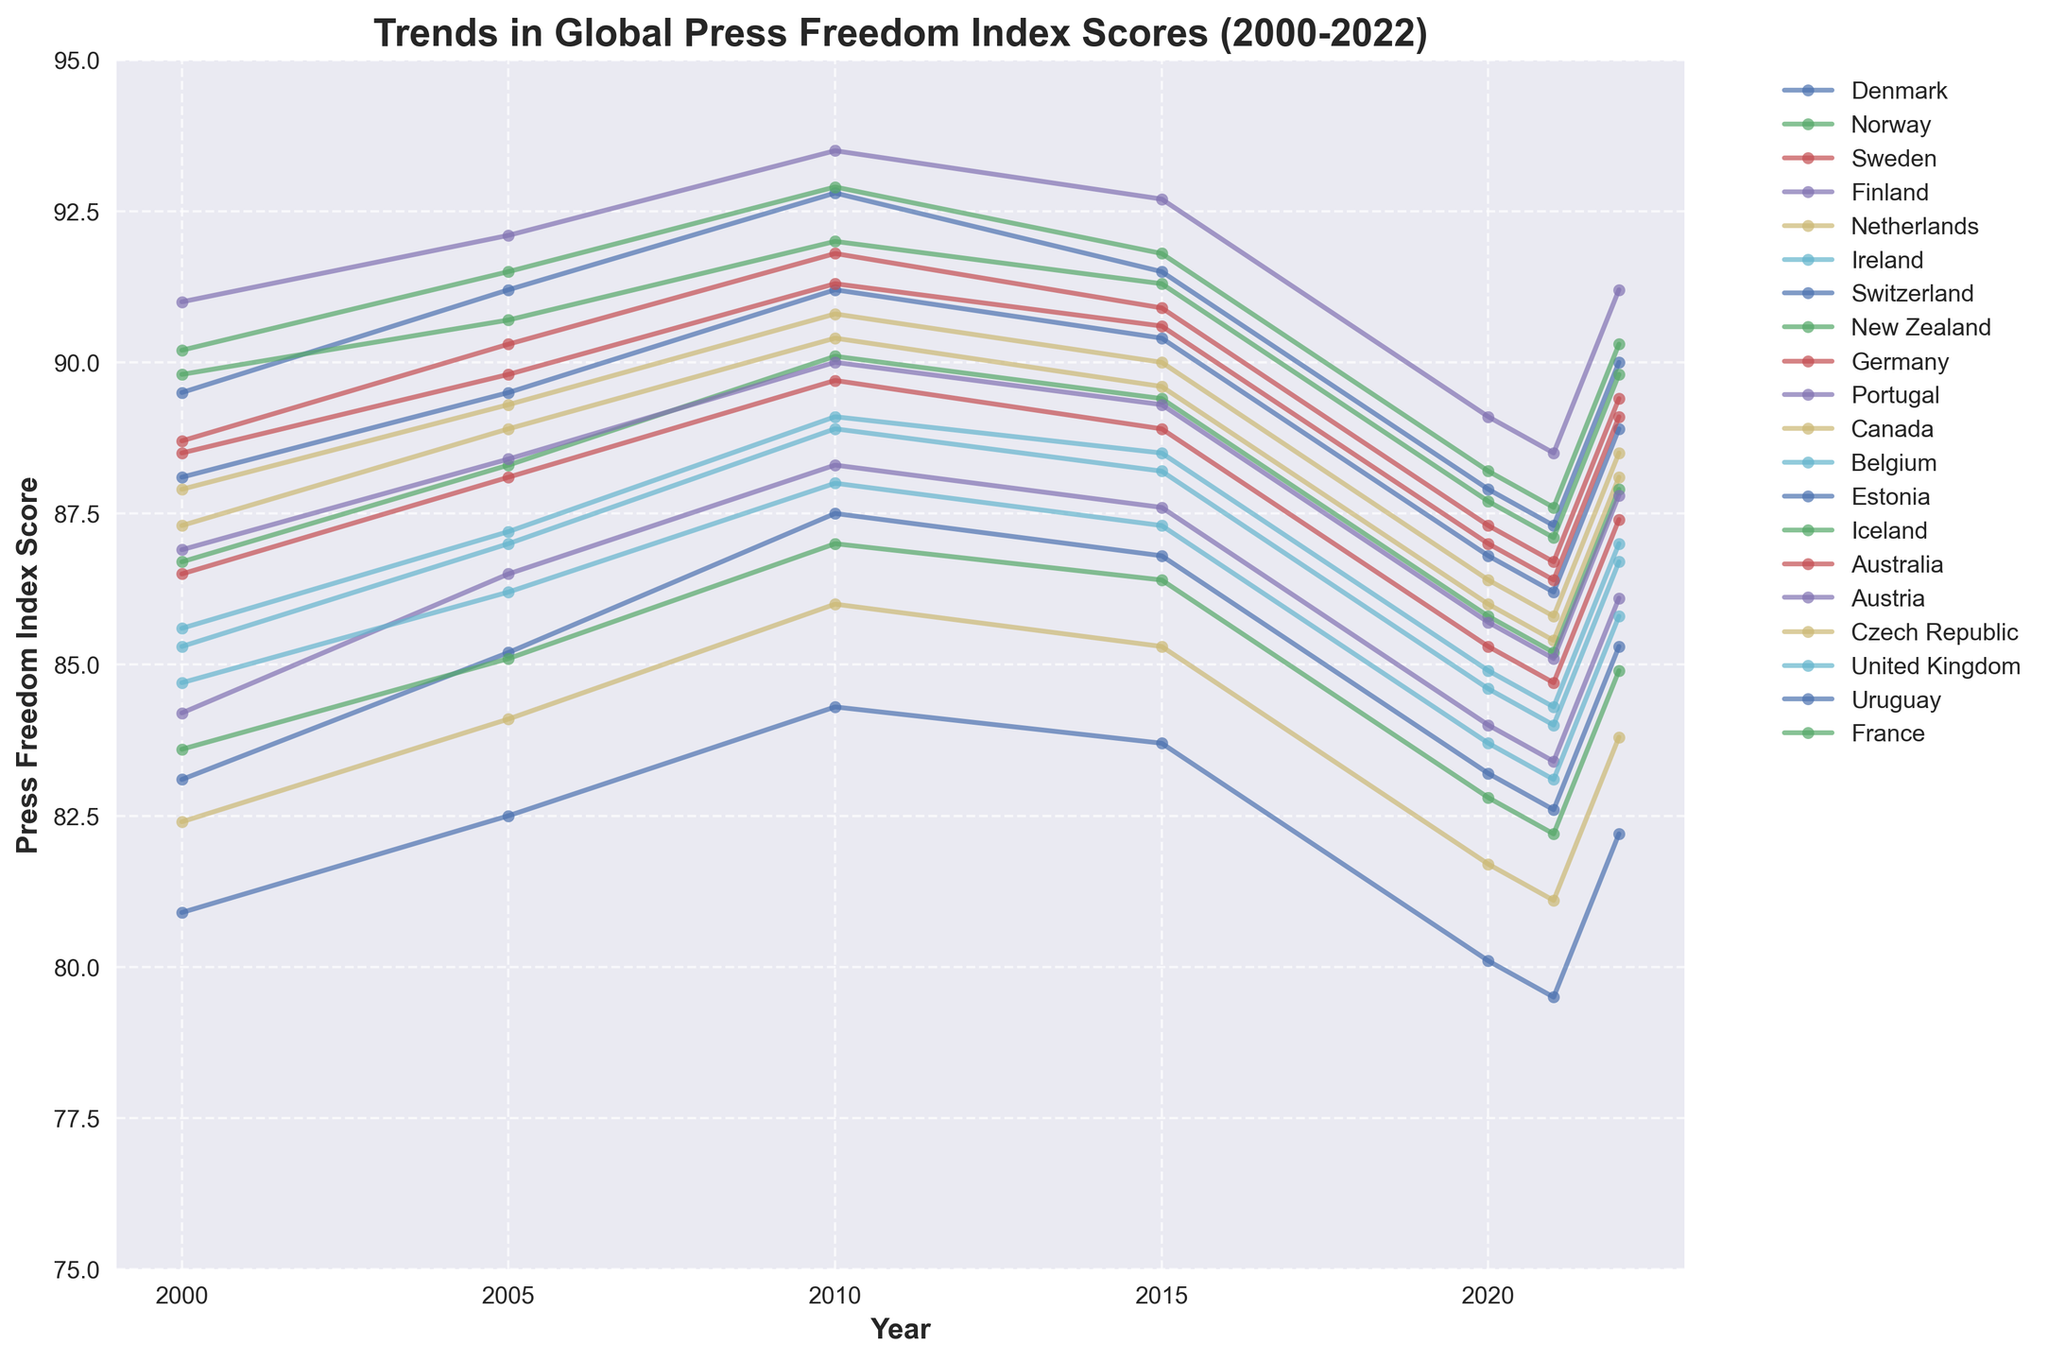What trend is seen in Iceland's press freedom index score from 2000 to 2022? Iceland's scores show a generally increasing then slightly declining trend. It starts at 86.7 in 2000, peaks in 2010 at 90.1, and later decreases to 85.2 in 2021 before rising again to 87.9 in 2022.
Answer: An overall rise, then decline, followed by a slight recovery How does Norway's press freedom index score in 2022 compare to its score in 2000? Norway's score in 2000 is 90.2. In 2022, it is 90.3. Comparing the two, there is a marginal increase of 0.1 points in 2022.
Answer: Slightly higher in 2022 Which country showed the largest increase in press freedom index score from 2021 to 2022? The country with the largest increase between 2021 and 2022 is New Zealand, increasing from 87.1 to 89.8, a change of 2.7 points.
Answer: New Zealand Which country had the lowest press freedom index score in 2005, and what was the score? In 2005, the country with the lowest score was Uruguay with a score of 82.5.
Answer: Uruguay, 82.5 What are the three highest press freedom index scores in 2010? The three highest scores in 2010 are Finland (93.5), Norway (92.9), and Denmark (92.8).
Answer: Finland, Norway, Denmark Compare the trends in press freedom index scores for Germany and France from 2000 to 2022. Germany starts at 86.5 in 2000, peaks in 2010 at 89.7, and declines to 87.4 in 2022. France starts at 83.6 in 2000, increases over time, peaks at 87.0 (2010), and reduces to 84.9 in 2022. While both countries show declines towards 2022, Germany's score remains consistently higher than France's over the period.
Answer: Germany consistently higher, both declined towards 2022 In which year did Ireland have its highest press freedom index score in the given data, and what was the score? Ireland's highest score is in 2010, with a score of 89.1.
Answer: 2010, 89.1 Did any country's press freedom index score drop continuously between three consecutive time intervals? If yes, name the country. France's score dropped continuously in 2010, 2015, and 2020 from 87.0 to 86.4 and then to 82.8.
Answer: France 